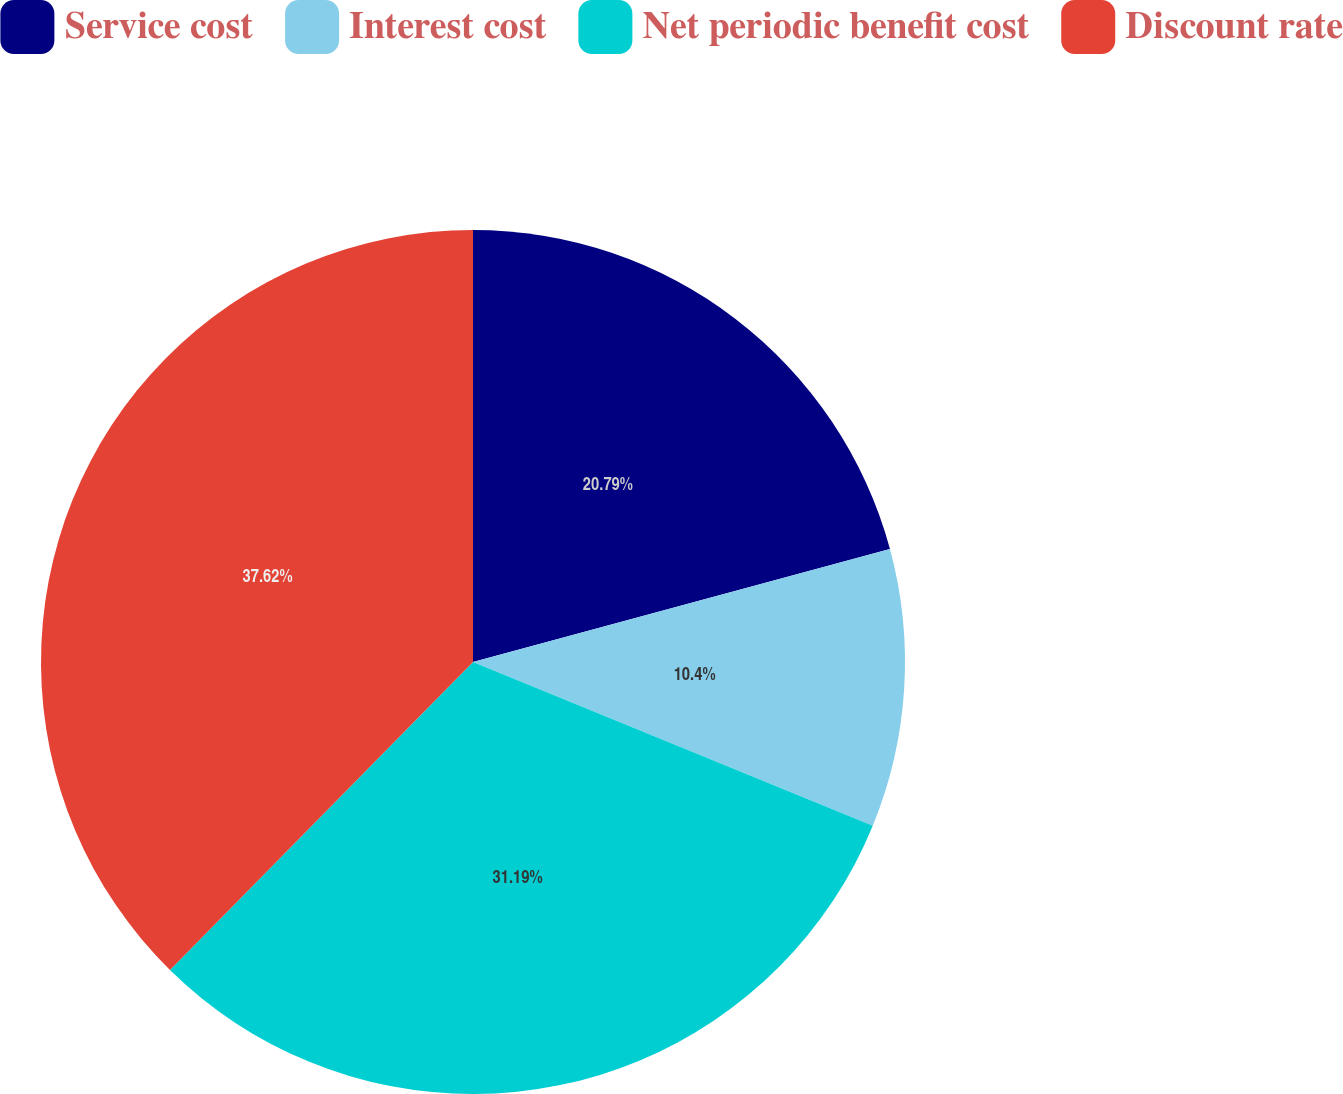Convert chart. <chart><loc_0><loc_0><loc_500><loc_500><pie_chart><fcel>Service cost<fcel>Interest cost<fcel>Net periodic benefit cost<fcel>Discount rate<nl><fcel>20.79%<fcel>10.4%<fcel>31.19%<fcel>37.63%<nl></chart> 